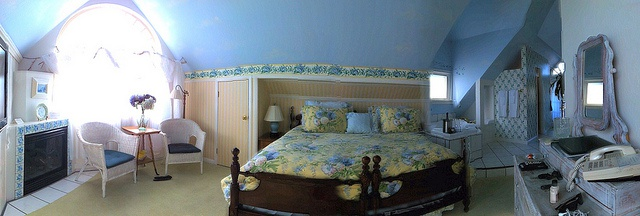Describe the objects in this image and their specific colors. I can see bed in lightblue, black, gray, darkgray, and olive tones, tv in lightblue, black, darkgray, and gray tones, chair in lightblue, darkgray, gray, and lavender tones, chair in lightblue, gray, darkgray, and black tones, and book in lightblue, black, blue, and gray tones in this image. 